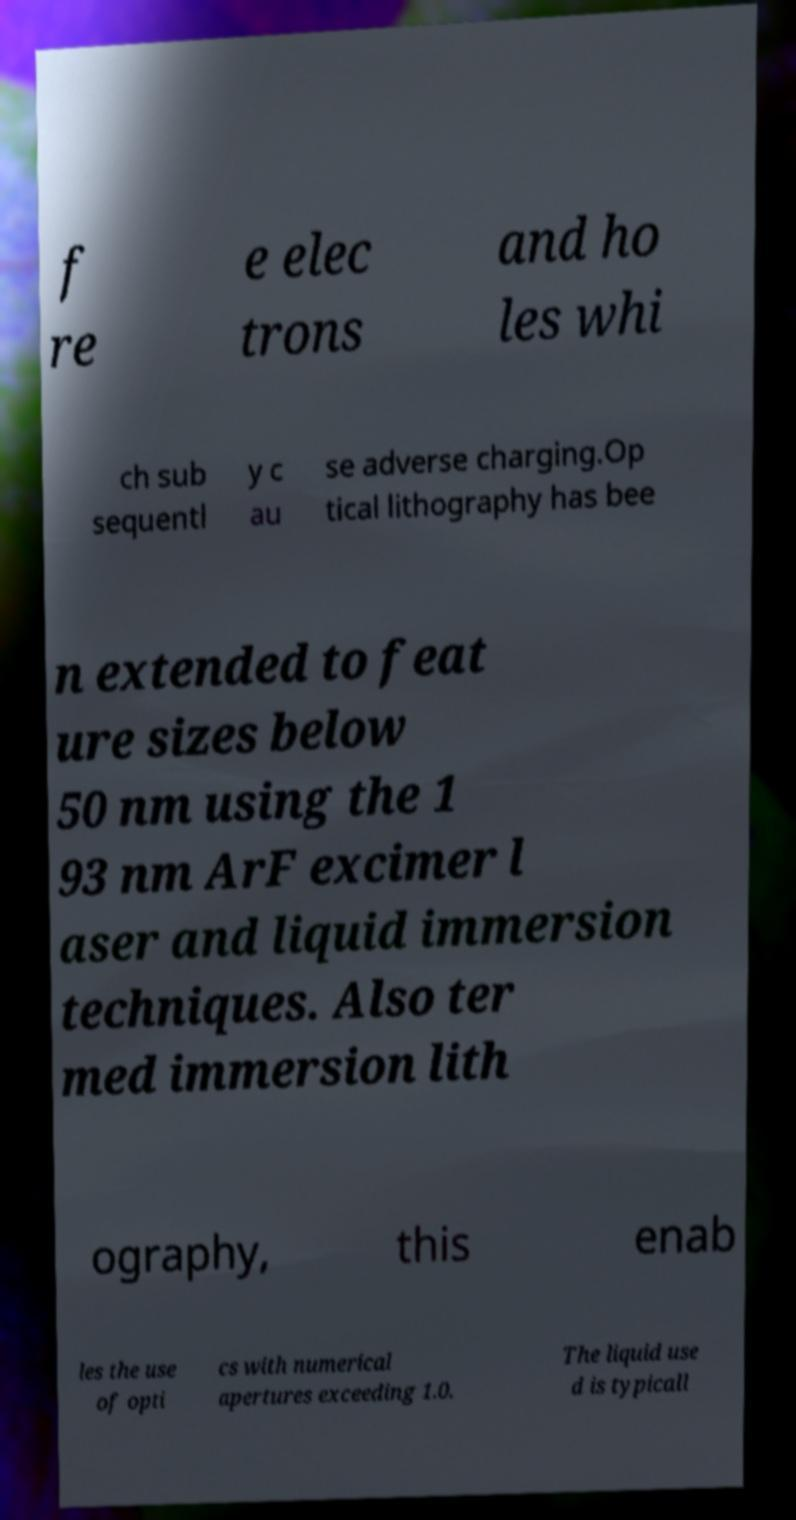Please read and relay the text visible in this image. What does it say? f re e elec trons and ho les whi ch sub sequentl y c au se adverse charging.Op tical lithography has bee n extended to feat ure sizes below 50 nm using the 1 93 nm ArF excimer l aser and liquid immersion techniques. Also ter med immersion lith ography, this enab les the use of opti cs with numerical apertures exceeding 1.0. The liquid use d is typicall 